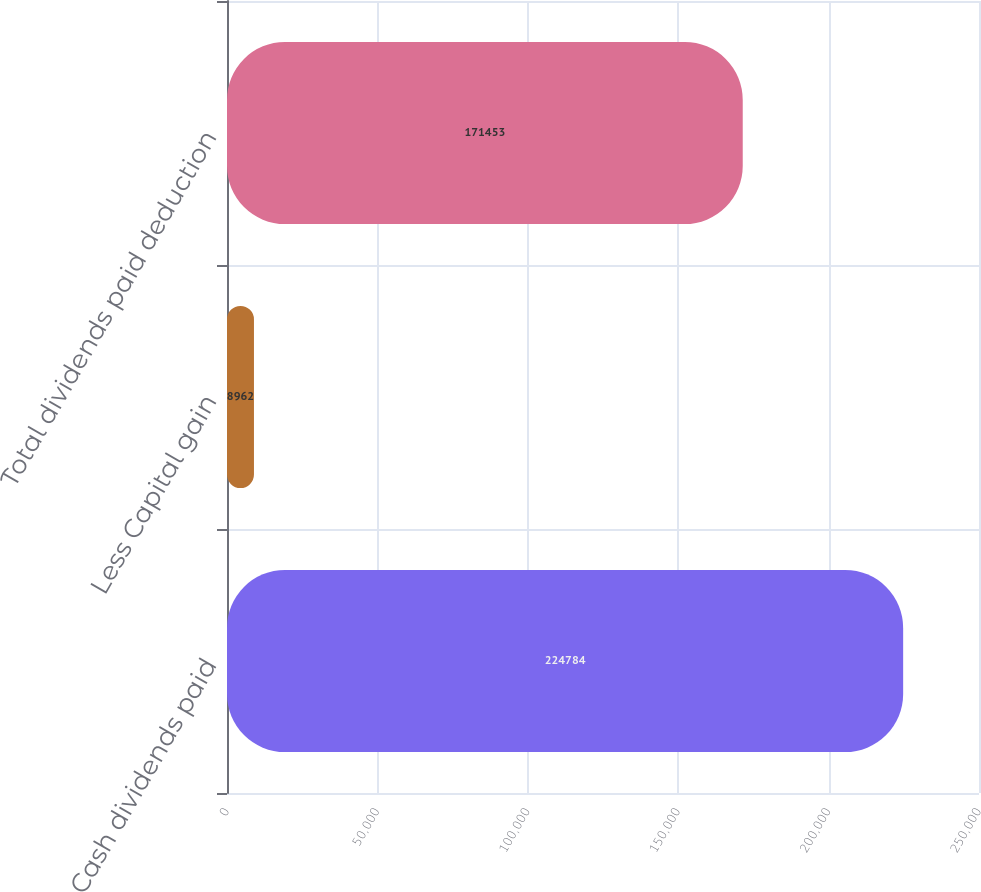<chart> <loc_0><loc_0><loc_500><loc_500><bar_chart><fcel>Cash dividends paid<fcel>Less Capital gain<fcel>Total dividends paid deduction<nl><fcel>224784<fcel>8962<fcel>171453<nl></chart> 